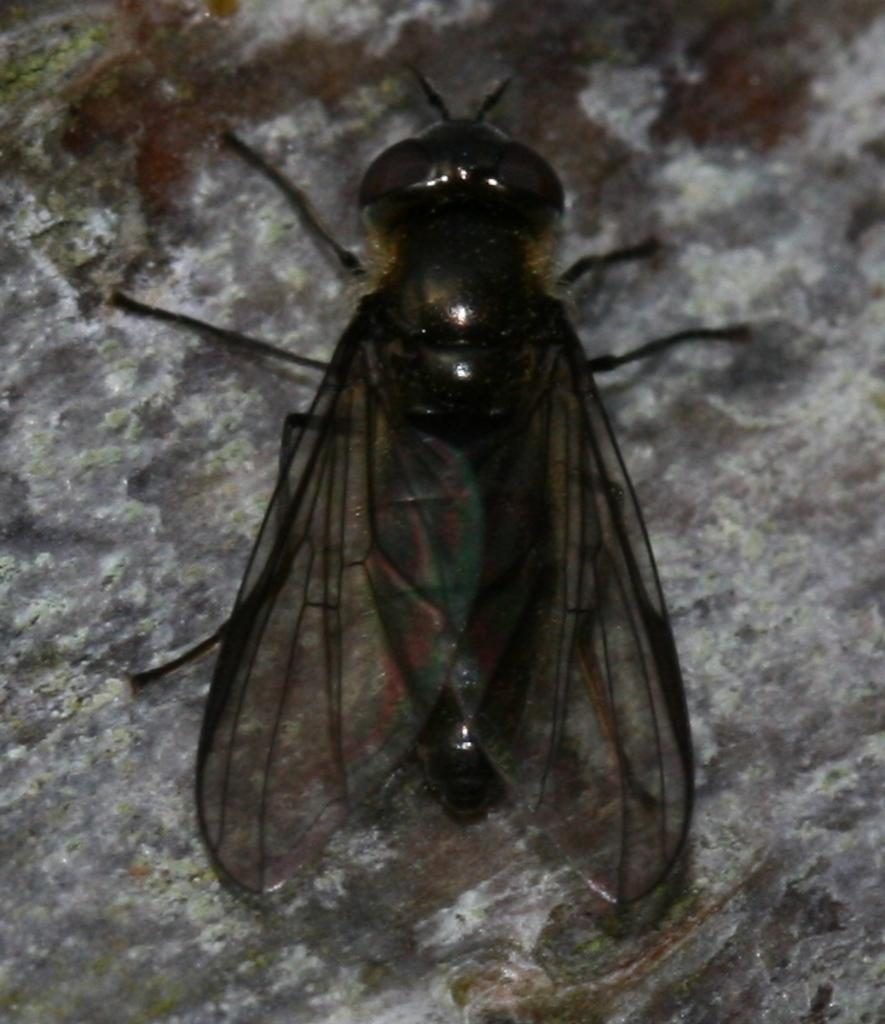What type of insect is in the image? There is a bee in the image. What color is the bee? The bee is black-colored. What is the bee doing in the image? The bee is flying and sitting on a stone. What type of voice does the bee have in the image? Bees do not have voices, so this cannot be determined from the image. 